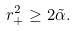<formula> <loc_0><loc_0><loc_500><loc_500>r _ { + } ^ { 2 } \geq 2 \tilde { \alpha } .</formula> 